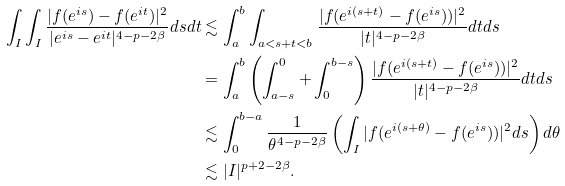<formula> <loc_0><loc_0><loc_500><loc_500>\int _ { I } \int _ { I } \frac { | f ( e ^ { i s } ) - f ( e ^ { i t } ) | ^ { 2 } } { | e ^ { i s } - e ^ { i t } | ^ { 4 - p - 2 \beta } } d s d t & \lesssim \int _ { a } ^ { b } \int _ { a < s + t < b } \frac { | f ( e ^ { i ( s + t ) } - f ( e ^ { i s } ) ) | ^ { 2 } } { | t | ^ { 4 - p - 2 \beta } } d t d s \\ & = \int _ { a } ^ { b } \left ( \int _ { a - s } ^ { 0 } + \int _ { 0 } ^ { b - s } \right ) \frac { | f ( e ^ { i ( s + t ) } - f ( e ^ { i s } ) ) | ^ { 2 } } { | t | ^ { 4 - p - 2 \beta } } d t d s \\ & \lesssim \int _ { 0 } ^ { b - a } \frac { 1 } { \theta ^ { 4 - p - 2 \beta } } \left ( \int _ { I } | f ( e ^ { i ( s + \theta ) } - f ( e ^ { i s } ) ) | ^ { 2 } d s \right ) d \theta \\ & \lesssim | I | ^ { p + 2 - 2 \beta } .</formula> 